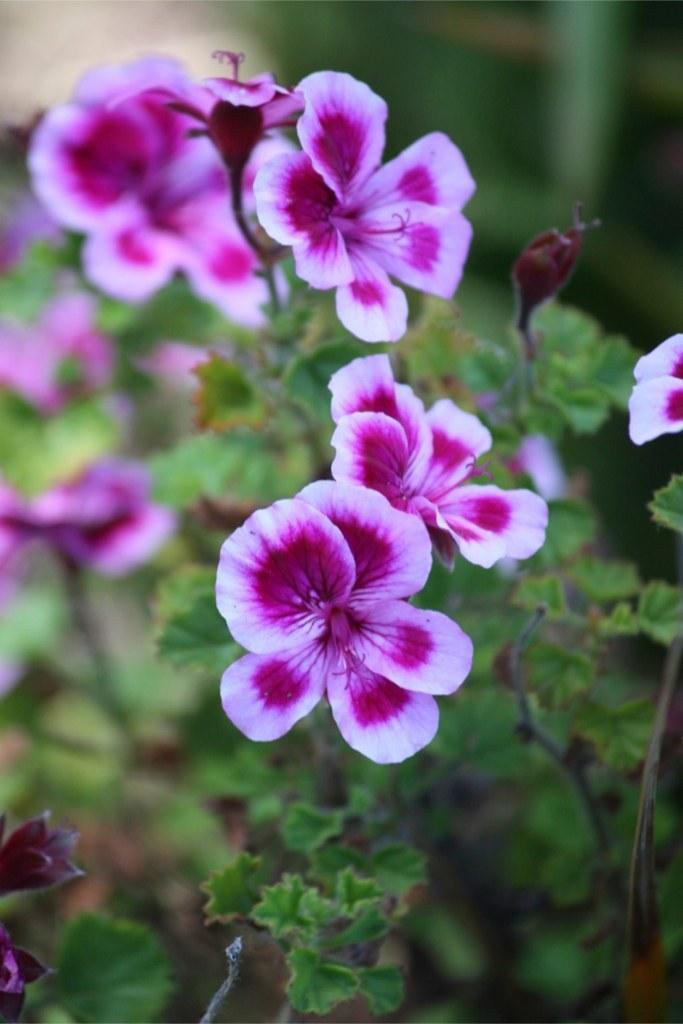What type of plants can be seen in the image? There are flowers in the image. What colors are the flowers? The flowers are in purple and white colors. What other part of the plant is visible in the image? There are green leaves in the image. What type of railway can be seen in the image? There is no railway present in the image; it features flowers and green leaves. How does the wave affect the flowers in the image? There is no wave present in the image, so its effect on the flowers cannot be determined. 